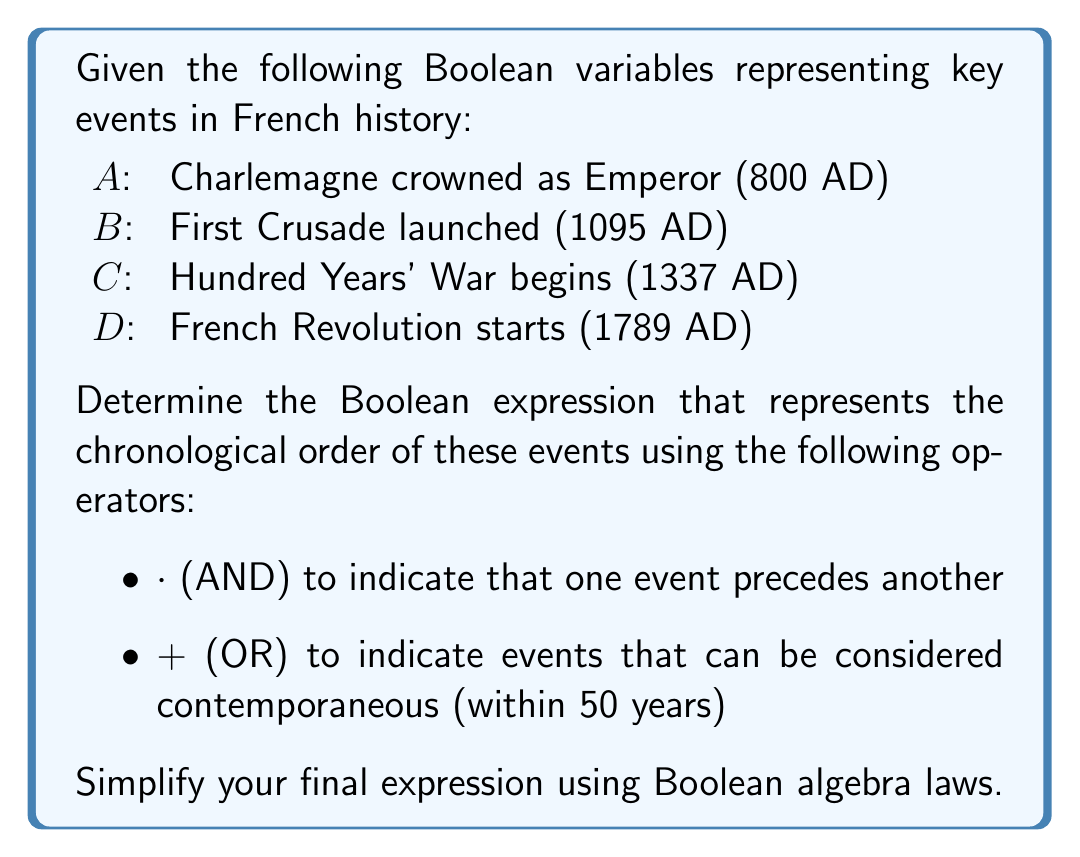Can you solve this math problem? To solve this problem, we need to construct a Boolean expression that represents the chronological order of events while considering the given operators:

1. First, let's arrange the events in chronological order:
   $A \rightarrow B \rightarrow C \rightarrow D$

2. Now, we can construct the initial Boolean expression:
   $A \cdot B \cdot C \cdot D$

3. We need to consider if any events can be considered contemporaneous (within 50 years):
   - $A$ and $B$ are not within 50 years (295 years apart)
   - $B$ and $C$ are not within 50 years (242 years apart)
   - $C$ and $D$ are not within 50 years (452 years apart)

4. Since no events are contemporaneous, we don't need to use the OR operator.

5. The final Boolean expression remains:
   $A \cdot B \cdot C \cdot D$

6. This expression cannot be further simplified using Boolean algebra laws, as it already represents the most basic form of the chronological order.

Therefore, the simplified Boolean expression representing the chronological order of these French historical events is $A \cdot B \cdot C \cdot D$.
Answer: $A \cdot B \cdot C \cdot D$ 